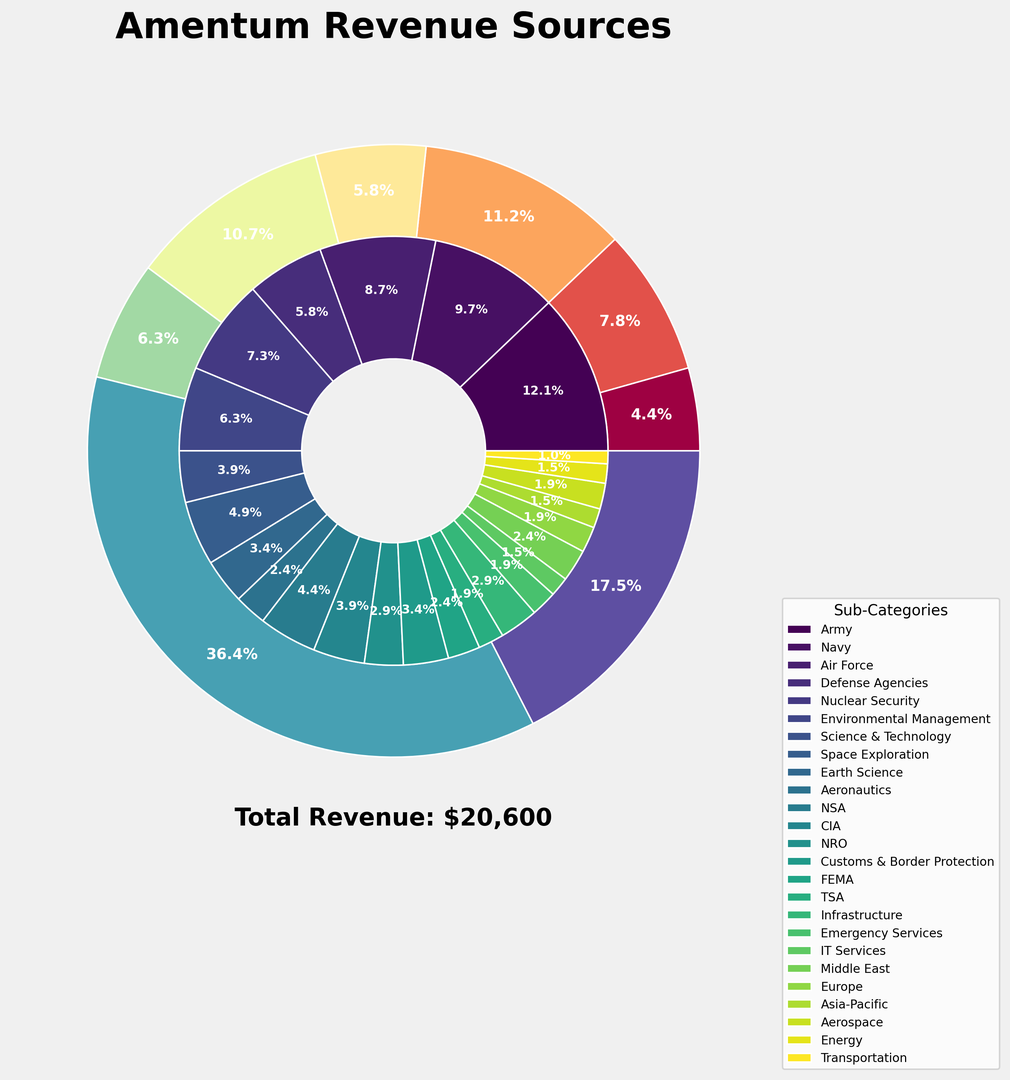Which client contributes the most to Amentum's total revenue? By examining the outer pie chart, you can quickly identify the largest segment.
Answer: U.S. Department of Defense What is the total revenue generated by NASA? By summing NASA's sub-categories: $1000M (Space Exploration) + $700M (Earth Science) + $500M (Aeronautics) = $2200M
Answer: $2200M Which is higher: the revenue from U.S. Department of Energy's Nuclear Security or NASA's Space Exploration? By looking at the inner pie chart, compare the sizes and revenues: Nuclear Security ($1500M) vs. Space Exploration ($1000M)
Answer: Nuclear Security In terms of sub-categories, which generates more revenue: the Intelligence Community's NSA or the Department of Homeland Security's Customs & Border Protection? Check the inner segments and compare NSA ($900M) and Customs & Border Protection ($700M)
Answer: NSA What percentage of the total revenue is generated by State & Local Governments? Refer to the outer pie chart, where State & Local Governments' segment is labeled with its percentage.
Answer: 4.4% If you combine the revenue from U.S. Department of Defense's Air Force and Navy, what is the combined revenue? Air Force ($1800M) + Navy ($2000M) = $3800M
Answer: $3800M Which sub-category within the U.S. Department of Defense generates the least revenue? By looking at the inner segments for U.S. Department of Defense, Defense Agencies have the smallest revenue of $1200M.
Answer: Defense Agencies How does the revenue from the Commercial Sector's Aerospace compare to International Clients' Europe? Compare the two inner segments: Aerospace ($400M) vs. Europe ($400M); both are equal.
Answer: Equal What is the total revenue for the U.S. Department of Energy? Summing its sub-categories: $1500M (Nuclear Security) + $1300M (Environmental Management) + $800M (Science & Technology) = $3600M
Answer: $3600M Which sub-category has the smallest revenue amongst all clients? Examine the inner segments and identify the smallest one: Commercial Sector's Transportation with $200M.
Answer: Transportation 